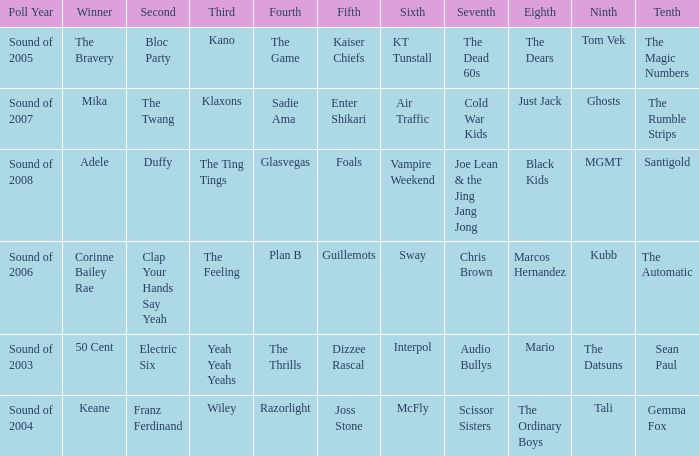When Kubb is in 9th, who is in 10th? The Automatic. 